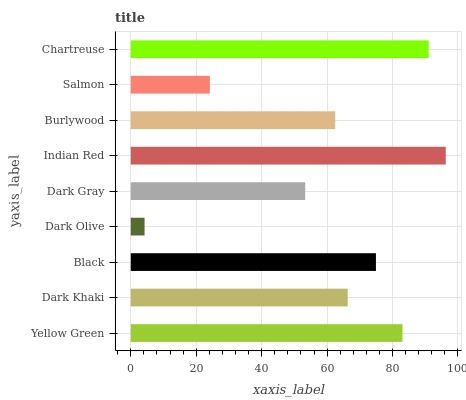Is Dark Olive the minimum?
Answer yes or no. Yes. Is Indian Red the maximum?
Answer yes or no. Yes. Is Dark Khaki the minimum?
Answer yes or no. No. Is Dark Khaki the maximum?
Answer yes or no. No. Is Yellow Green greater than Dark Khaki?
Answer yes or no. Yes. Is Dark Khaki less than Yellow Green?
Answer yes or no. Yes. Is Dark Khaki greater than Yellow Green?
Answer yes or no. No. Is Yellow Green less than Dark Khaki?
Answer yes or no. No. Is Dark Khaki the high median?
Answer yes or no. Yes. Is Dark Khaki the low median?
Answer yes or no. Yes. Is Burlywood the high median?
Answer yes or no. No. Is Burlywood the low median?
Answer yes or no. No. 